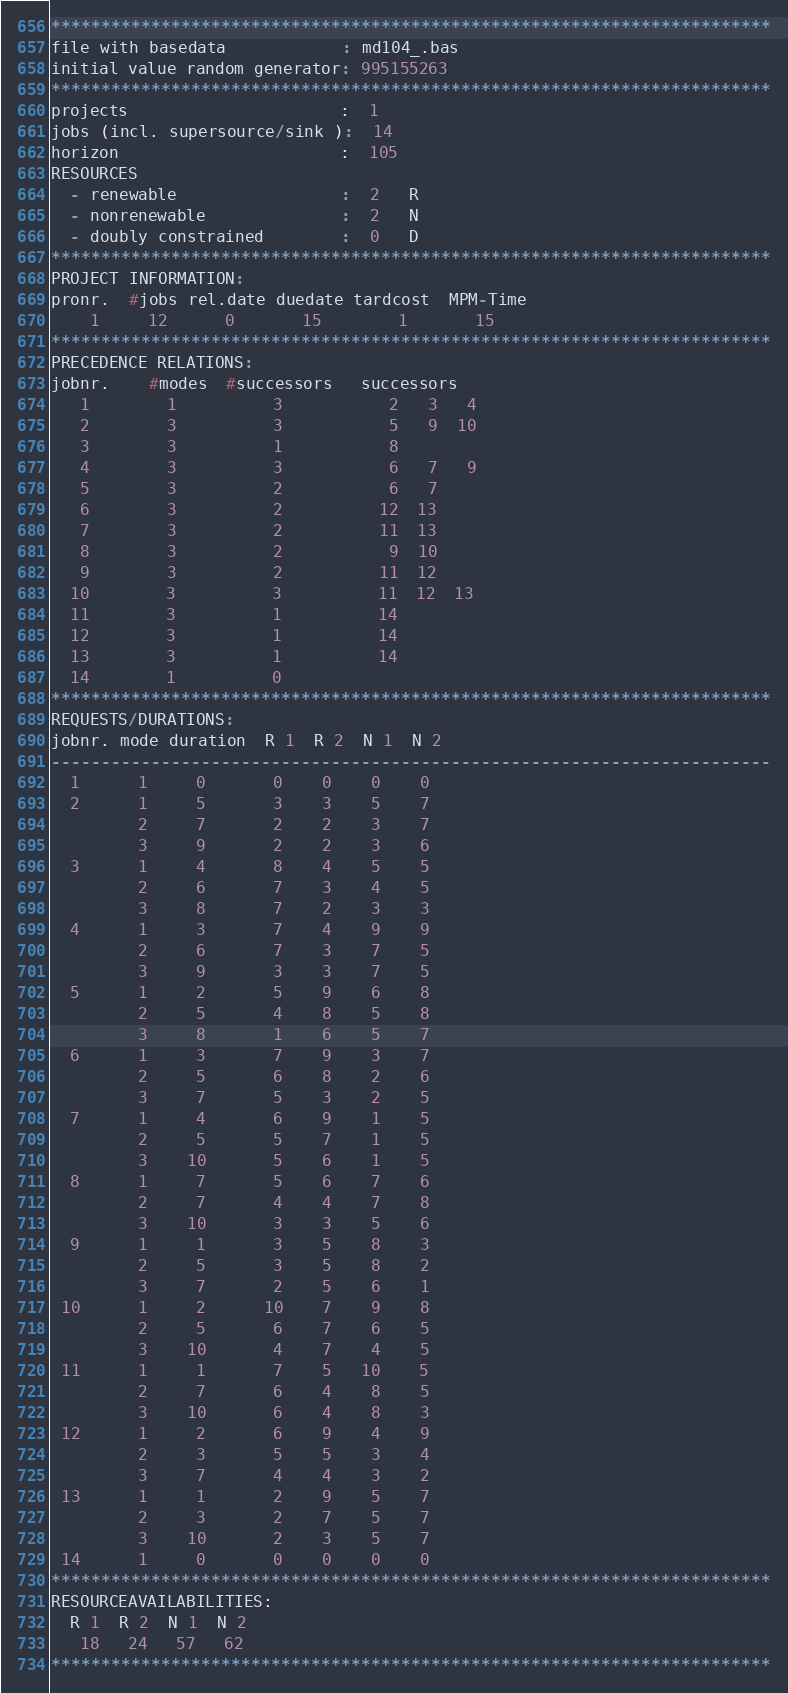<code> <loc_0><loc_0><loc_500><loc_500><_ObjectiveC_>************************************************************************
file with basedata            : md104_.bas
initial value random generator: 995155263
************************************************************************
projects                      :  1
jobs (incl. supersource/sink ):  14
horizon                       :  105
RESOURCES
  - renewable                 :  2   R
  - nonrenewable              :  2   N
  - doubly constrained        :  0   D
************************************************************************
PROJECT INFORMATION:
pronr.  #jobs rel.date duedate tardcost  MPM-Time
    1     12      0       15        1       15
************************************************************************
PRECEDENCE RELATIONS:
jobnr.    #modes  #successors   successors
   1        1          3           2   3   4
   2        3          3           5   9  10
   3        3          1           8
   4        3          3           6   7   9
   5        3          2           6   7
   6        3          2          12  13
   7        3          2          11  13
   8        3          2           9  10
   9        3          2          11  12
  10        3          3          11  12  13
  11        3          1          14
  12        3          1          14
  13        3          1          14
  14        1          0        
************************************************************************
REQUESTS/DURATIONS:
jobnr. mode duration  R 1  R 2  N 1  N 2
------------------------------------------------------------------------
  1      1     0       0    0    0    0
  2      1     5       3    3    5    7
         2     7       2    2    3    7
         3     9       2    2    3    6
  3      1     4       8    4    5    5
         2     6       7    3    4    5
         3     8       7    2    3    3
  4      1     3       7    4    9    9
         2     6       7    3    7    5
         3     9       3    3    7    5
  5      1     2       5    9    6    8
         2     5       4    8    5    8
         3     8       1    6    5    7
  6      1     3       7    9    3    7
         2     5       6    8    2    6
         3     7       5    3    2    5
  7      1     4       6    9    1    5
         2     5       5    7    1    5
         3    10       5    6    1    5
  8      1     7       5    6    7    6
         2     7       4    4    7    8
         3    10       3    3    5    6
  9      1     1       3    5    8    3
         2     5       3    5    8    2
         3     7       2    5    6    1
 10      1     2      10    7    9    8
         2     5       6    7    6    5
         3    10       4    7    4    5
 11      1     1       7    5   10    5
         2     7       6    4    8    5
         3    10       6    4    8    3
 12      1     2       6    9    4    9
         2     3       5    5    3    4
         3     7       4    4    3    2
 13      1     1       2    9    5    7
         2     3       2    7    5    7
         3    10       2    3    5    7
 14      1     0       0    0    0    0
************************************************************************
RESOURCEAVAILABILITIES:
  R 1  R 2  N 1  N 2
   18   24   57   62
************************************************************************
</code> 